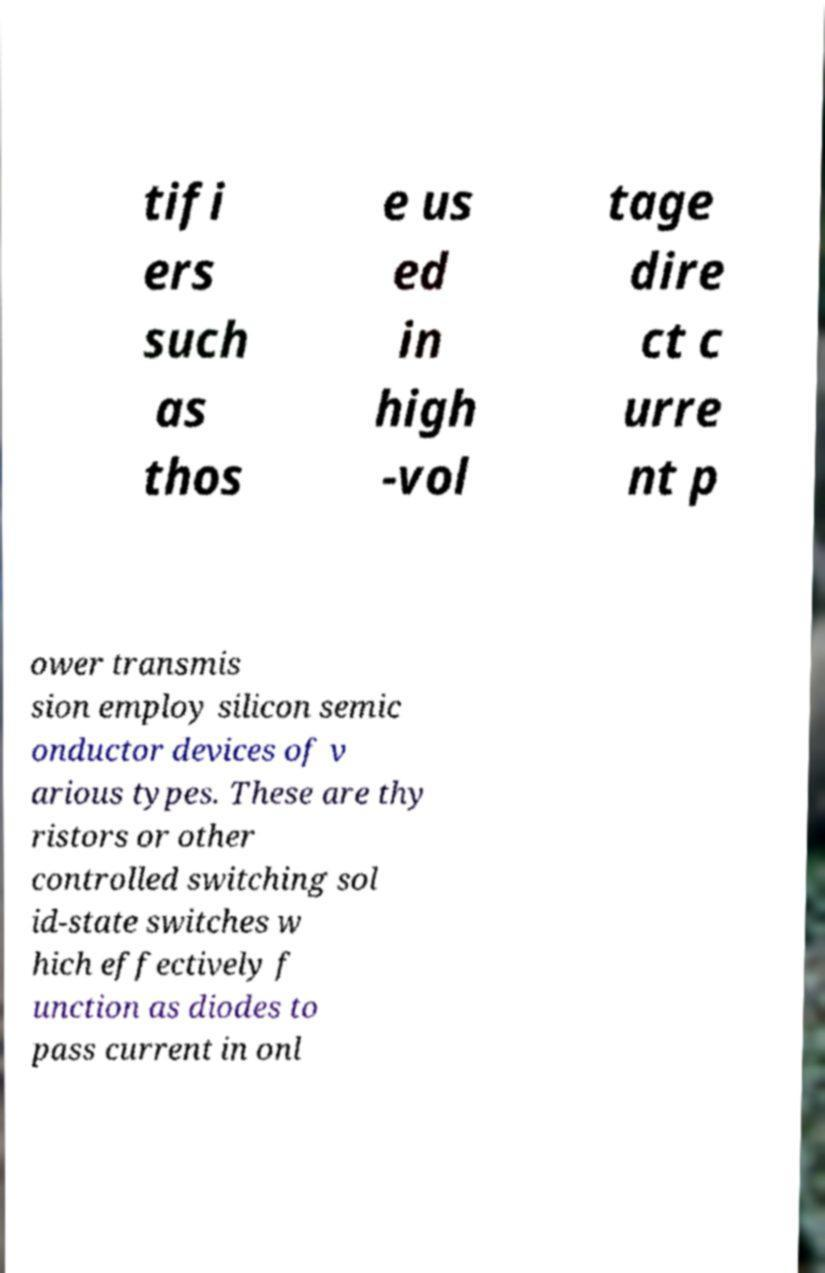I need the written content from this picture converted into text. Can you do that? tifi ers such as thos e us ed in high -vol tage dire ct c urre nt p ower transmis sion employ silicon semic onductor devices of v arious types. These are thy ristors or other controlled switching sol id-state switches w hich effectively f unction as diodes to pass current in onl 